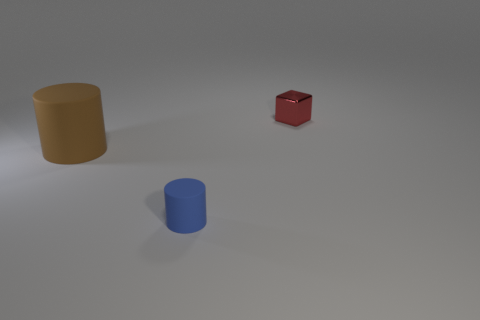What number of small red metallic cubes are there?
Your answer should be compact. 1. What number of blue things are made of the same material as the brown thing?
Keep it short and to the point. 1. There is a blue object that is the same shape as the big brown rubber thing; what size is it?
Make the answer very short. Small. What material is the big thing?
Offer a very short reply. Rubber. There is a cylinder in front of the large rubber cylinder that is behind the object that is in front of the brown object; what is it made of?
Provide a short and direct response. Rubber. Is there any other thing that has the same shape as the blue object?
Make the answer very short. Yes. There is another object that is the same shape as the large brown thing; what is its color?
Give a very brief answer. Blue. Do the small object in front of the red cube and the object that is right of the blue rubber thing have the same color?
Provide a succinct answer. No. Are there more small blocks that are left of the small shiny cube than cylinders?
Offer a terse response. No. What number of other objects are there of the same size as the brown object?
Make the answer very short. 0. 